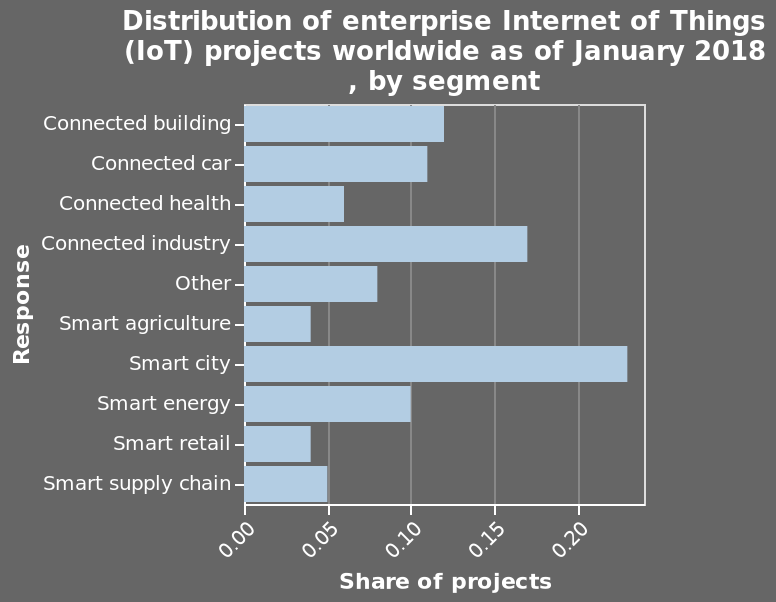<image>
How many responses have a share of at least 0.5 in projects? All but 3 responses have a share of at least 0.5 in projects. What does the bar chart represent? The bar chart represents the distribution of enterprise Internet of Things (IoT) projects worldwide as of January 2018, categorized by segment. 